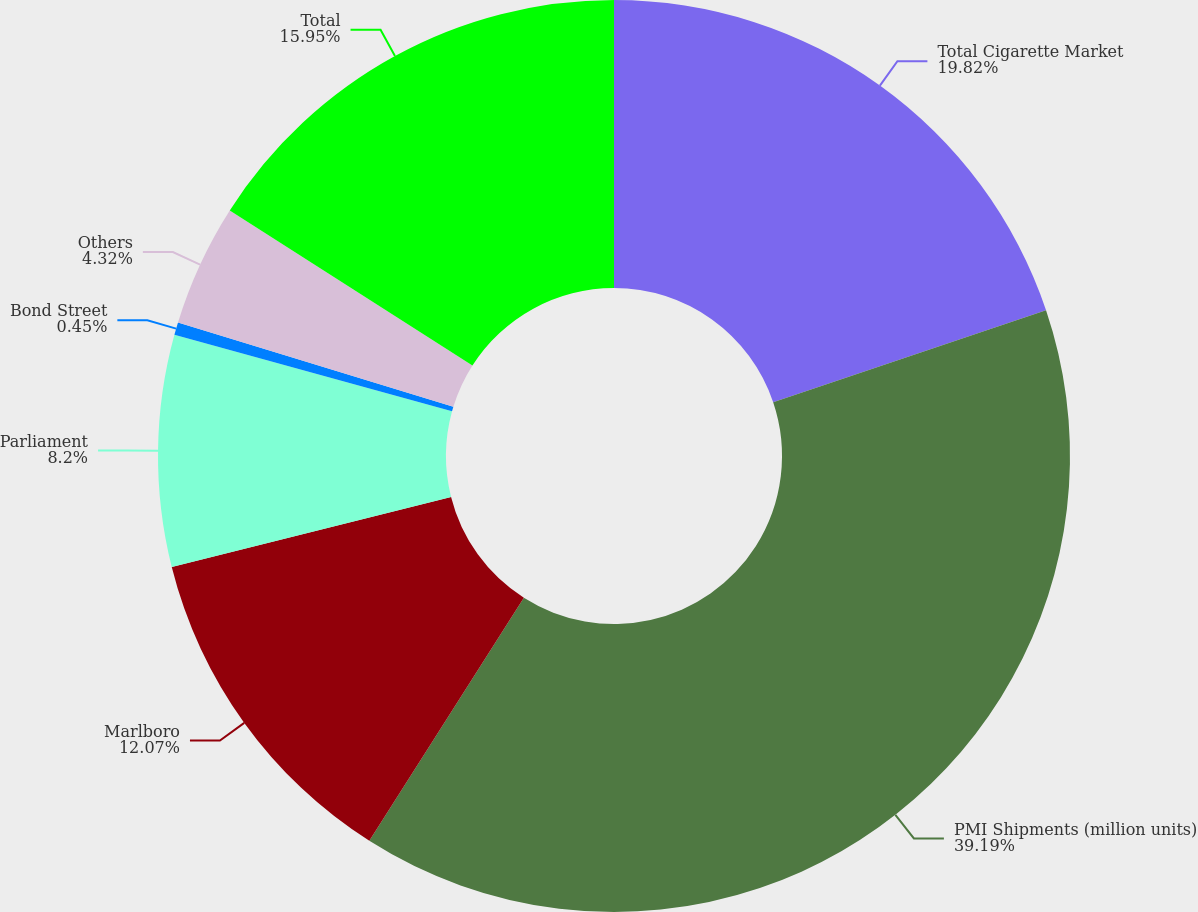Convert chart to OTSL. <chart><loc_0><loc_0><loc_500><loc_500><pie_chart><fcel>Total Cigarette Market<fcel>PMI Shipments (million units)<fcel>Marlboro<fcel>Parliament<fcel>Bond Street<fcel>Others<fcel>Total<nl><fcel>19.82%<fcel>39.2%<fcel>12.07%<fcel>8.2%<fcel>0.45%<fcel>4.32%<fcel>15.95%<nl></chart> 